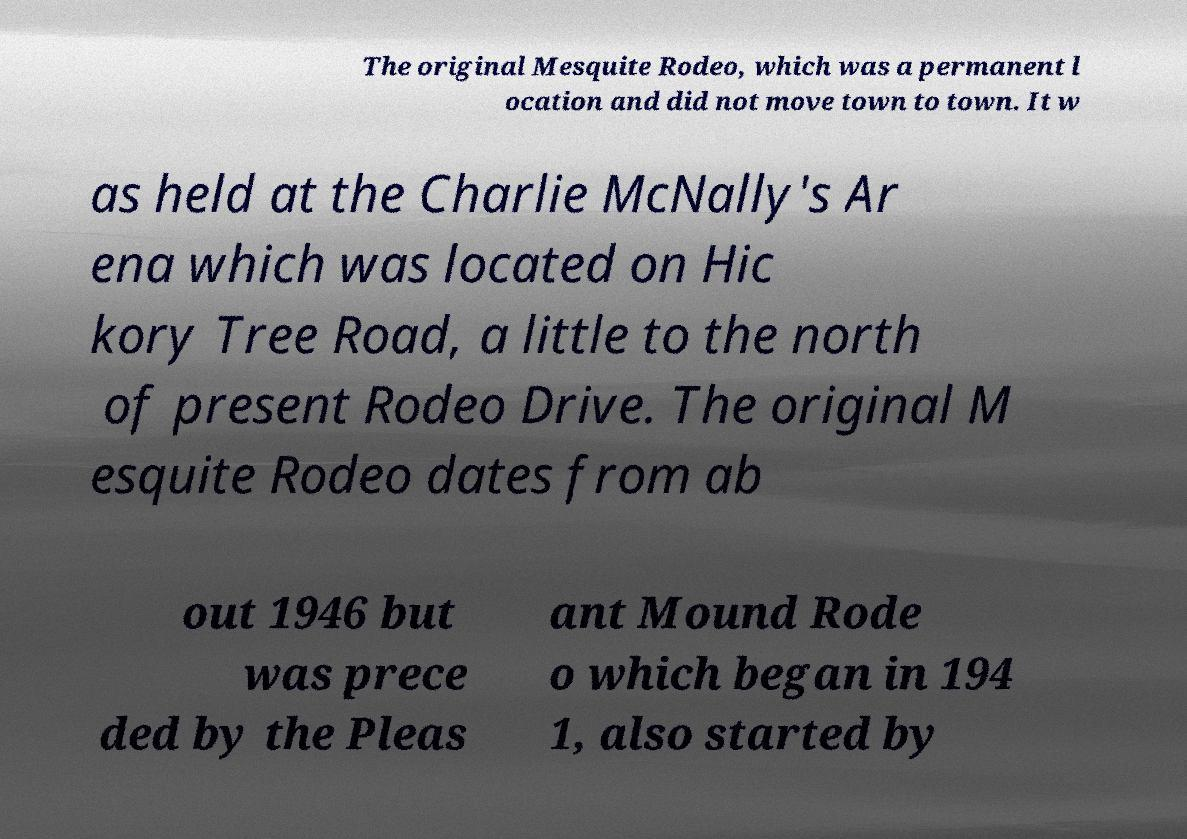Could you assist in decoding the text presented in this image and type it out clearly? The original Mesquite Rodeo, which was a permanent l ocation and did not move town to town. It w as held at the Charlie McNally's Ar ena which was located on Hic kory Tree Road, a little to the north of present Rodeo Drive. The original M esquite Rodeo dates from ab out 1946 but was prece ded by the Pleas ant Mound Rode o which began in 194 1, also started by 